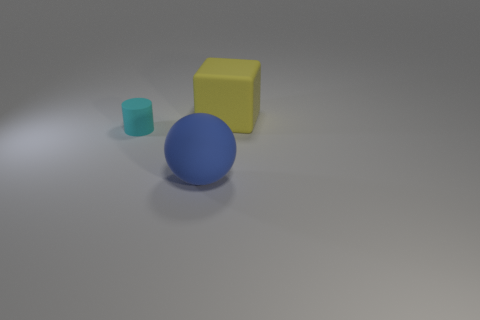Are there fewer large gray shiny blocks than rubber objects?
Give a very brief answer. Yes. The big thing that is in front of the large thing that is behind the large matte object that is to the left of the large block is what shape?
Offer a terse response. Sphere. Are there any blue balls that have the same material as the large yellow object?
Keep it short and to the point. Yes. There is a large thing that is left of the big matte block; is its color the same as the big rubber object right of the blue thing?
Provide a succinct answer. No. Is the number of blocks that are on the left side of the cyan rubber thing less than the number of tiny matte cylinders?
Make the answer very short. Yes. How many things are cyan cylinders or matte objects in front of the yellow matte thing?
Ensure brevity in your answer.  2. What is the color of the cylinder that is the same material as the large yellow block?
Ensure brevity in your answer.  Cyan. What number of objects are red cylinders or matte things?
Give a very brief answer. 3. There is a sphere that is the same size as the yellow cube; what color is it?
Offer a very short reply. Blue. What number of things are either large things that are in front of the small object or matte cylinders?
Your answer should be compact. 2. 